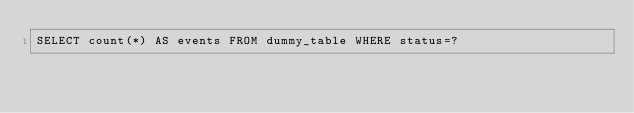<code> <loc_0><loc_0><loc_500><loc_500><_SQL_>SELECT count(*) AS events FROM dummy_table WHERE status=?</code> 